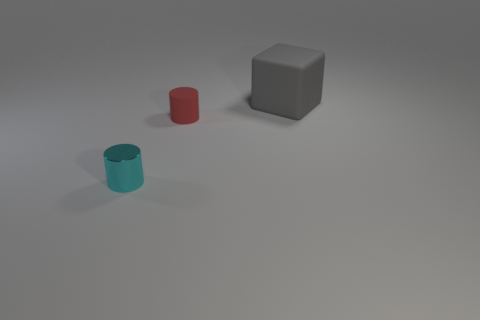Add 2 tiny cyan metallic cylinders. How many objects exist? 5 Subtract all cylinders. How many objects are left? 1 Subtract 0 blue balls. How many objects are left? 3 Subtract all tiny cyan rubber blocks. Subtract all gray matte things. How many objects are left? 2 Add 1 tiny cyan metallic things. How many tiny cyan metallic things are left? 2 Add 3 small metallic things. How many small metallic things exist? 4 